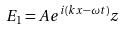Convert formula to latex. <formula><loc_0><loc_0><loc_500><loc_500>E _ { 1 } = A e ^ { i ( k x - \omega t ) } z</formula> 